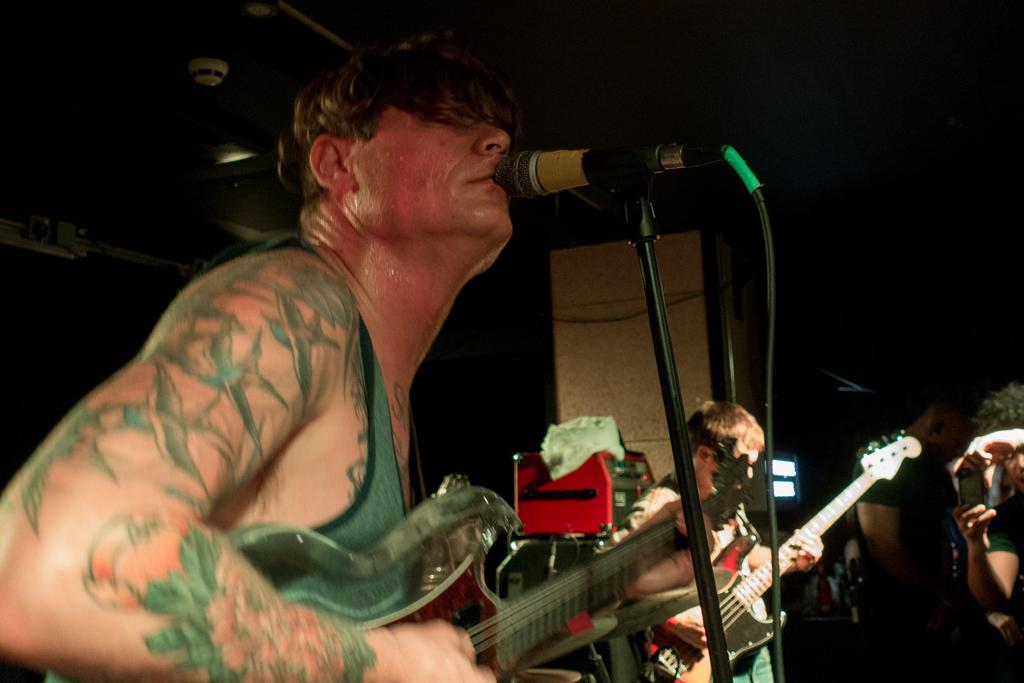How many people are in the image? There are two persons in the image. What are the two persons doing in the image? The two persons are playing guitar. Can you describe any additional equipment or objects in the image? There is a microphone in front of one of the persons. What type of bird can be seen flying in the image? There are no birds present in the image; it features two persons playing guitar and a microphone. 